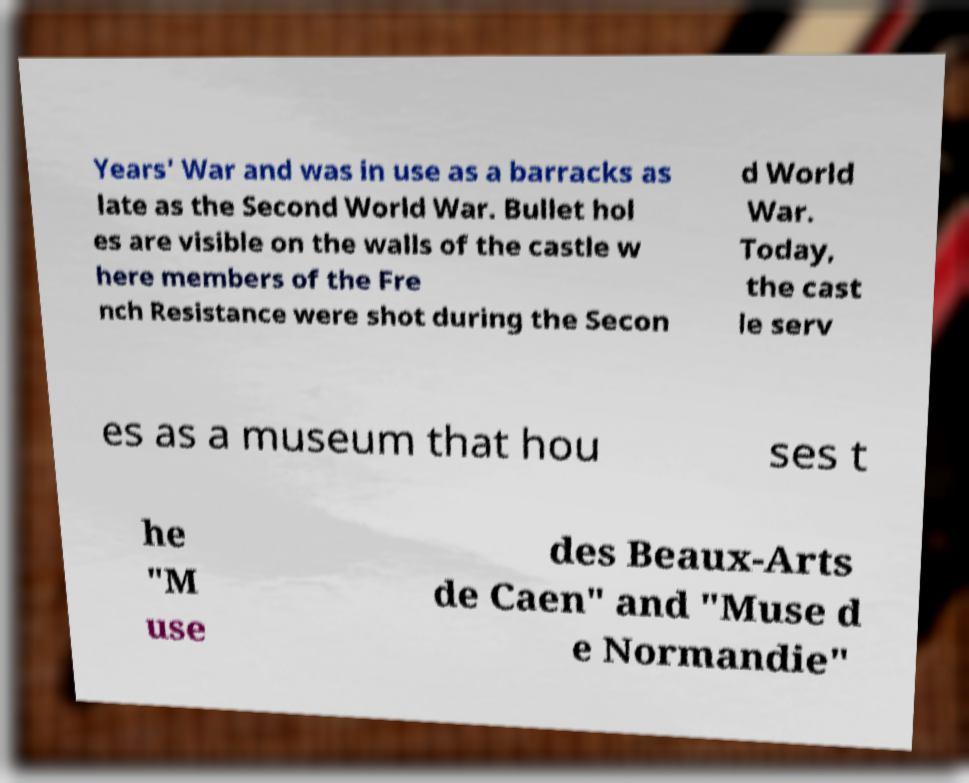What messages or text are displayed in this image? I need them in a readable, typed format. Years' War and was in use as a barracks as late as the Second World War. Bullet hol es are visible on the walls of the castle w here members of the Fre nch Resistance were shot during the Secon d World War. Today, the cast le serv es as a museum that hou ses t he "M use des Beaux-Arts de Caen" and "Muse d e Normandie" 